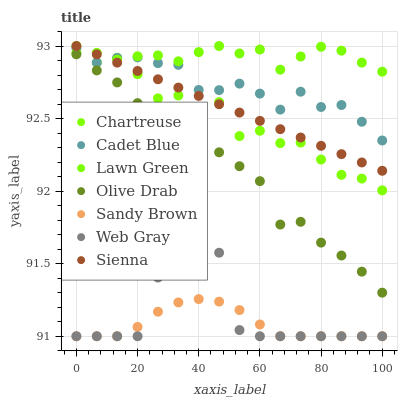Does Sandy Brown have the minimum area under the curve?
Answer yes or no. Yes. Does Lawn Green have the maximum area under the curve?
Answer yes or no. Yes. Does Web Gray have the minimum area under the curve?
Answer yes or no. No. Does Web Gray have the maximum area under the curve?
Answer yes or no. No. Is Sienna the smoothest?
Answer yes or no. Yes. Is Web Gray the roughest?
Answer yes or no. Yes. Is Web Gray the smoothest?
Answer yes or no. No. Is Sienna the roughest?
Answer yes or no. No. Does Web Gray have the lowest value?
Answer yes or no. Yes. Does Sienna have the lowest value?
Answer yes or no. No. Does Chartreuse have the highest value?
Answer yes or no. Yes. Does Web Gray have the highest value?
Answer yes or no. No. Is Web Gray less than Sienna?
Answer yes or no. Yes. Is Cadet Blue greater than Sandy Brown?
Answer yes or no. Yes. Does Chartreuse intersect Lawn Green?
Answer yes or no. Yes. Is Chartreuse less than Lawn Green?
Answer yes or no. No. Is Chartreuse greater than Lawn Green?
Answer yes or no. No. Does Web Gray intersect Sienna?
Answer yes or no. No. 